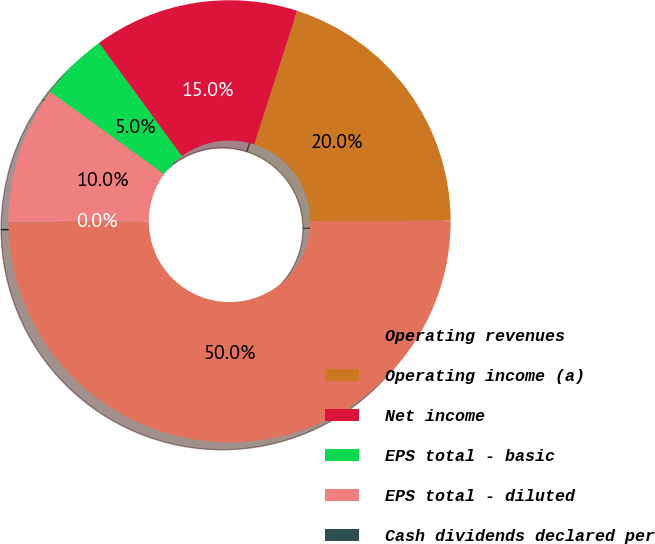Convert chart to OTSL. <chart><loc_0><loc_0><loc_500><loc_500><pie_chart><fcel>Operating revenues<fcel>Operating income (a)<fcel>Net income<fcel>EPS total - basic<fcel>EPS total - diluted<fcel>Cash dividends declared per<nl><fcel>49.99%<fcel>20.0%<fcel>15.0%<fcel>5.0%<fcel>10.0%<fcel>0.01%<nl></chart> 